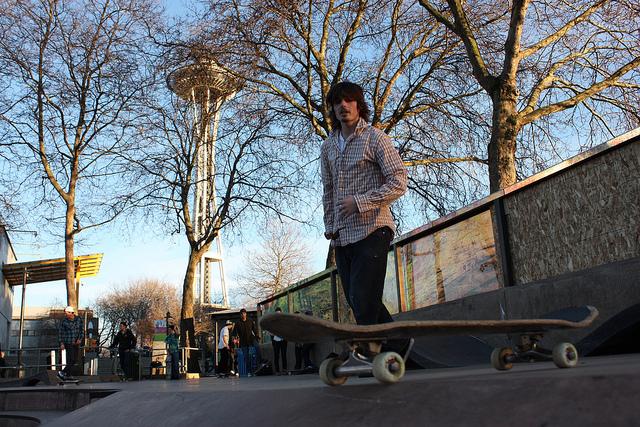What color are the wheels on the skateboard?
Answer briefly. White. How many wheels are on the skateboard?
Give a very brief answer. 4. What  is the name of the landmark in the background?
Answer briefly. Space needle. 